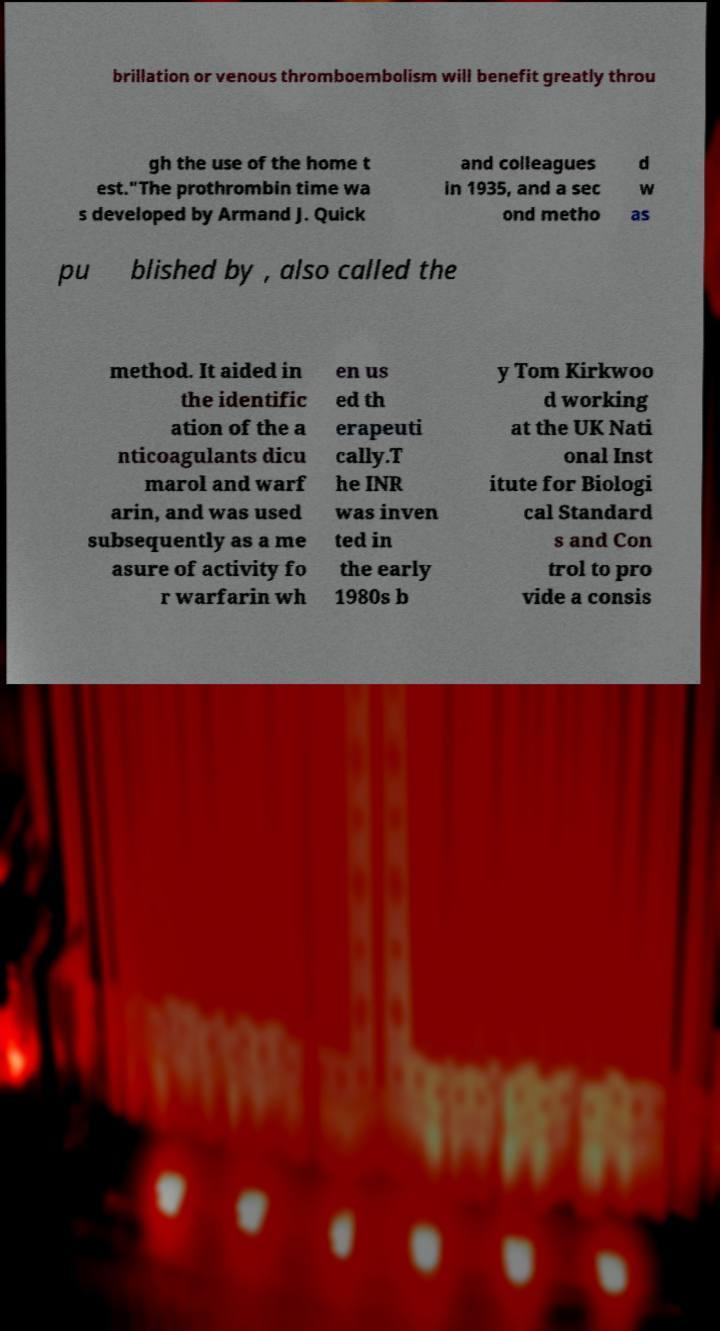What messages or text are displayed in this image? I need them in a readable, typed format. brillation or venous thromboembolism will benefit greatly throu gh the use of the home t est."The prothrombin time wa s developed by Armand J. Quick and colleagues in 1935, and a sec ond metho d w as pu blished by , also called the method. It aided in the identific ation of the a nticoagulants dicu marol and warf arin, and was used subsequently as a me asure of activity fo r warfarin wh en us ed th erapeuti cally.T he INR was inven ted in the early 1980s b y Tom Kirkwoo d working at the UK Nati onal Inst itute for Biologi cal Standard s and Con trol to pro vide a consis 